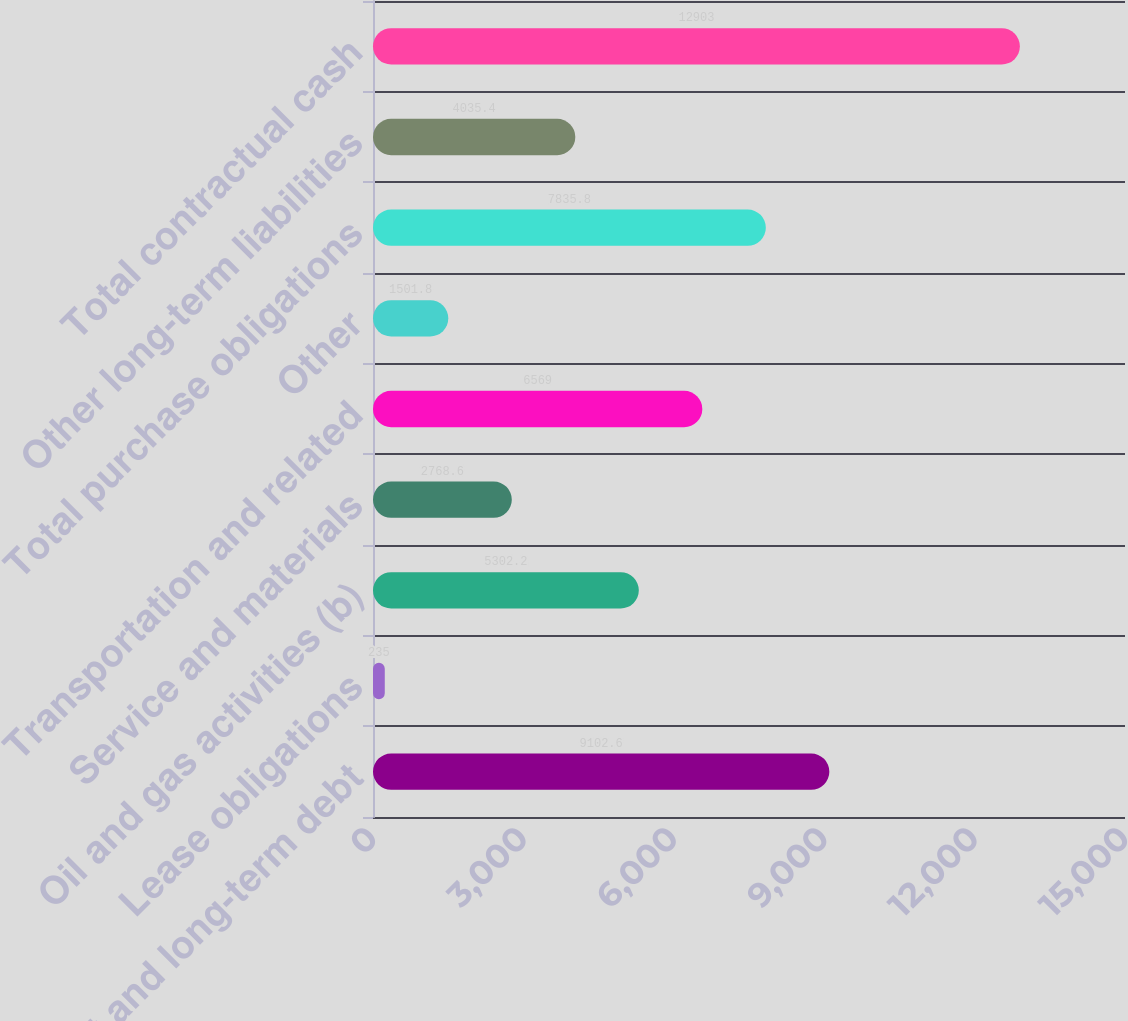Convert chart to OTSL. <chart><loc_0><loc_0><loc_500><loc_500><bar_chart><fcel>Short and long-term debt<fcel>Lease obligations<fcel>Oil and gas activities (b)<fcel>Service and materials<fcel>Transportation and related<fcel>Other<fcel>Total purchase obligations<fcel>Other long-term liabilities<fcel>Total contractual cash<nl><fcel>9102.6<fcel>235<fcel>5302.2<fcel>2768.6<fcel>6569<fcel>1501.8<fcel>7835.8<fcel>4035.4<fcel>12903<nl></chart> 